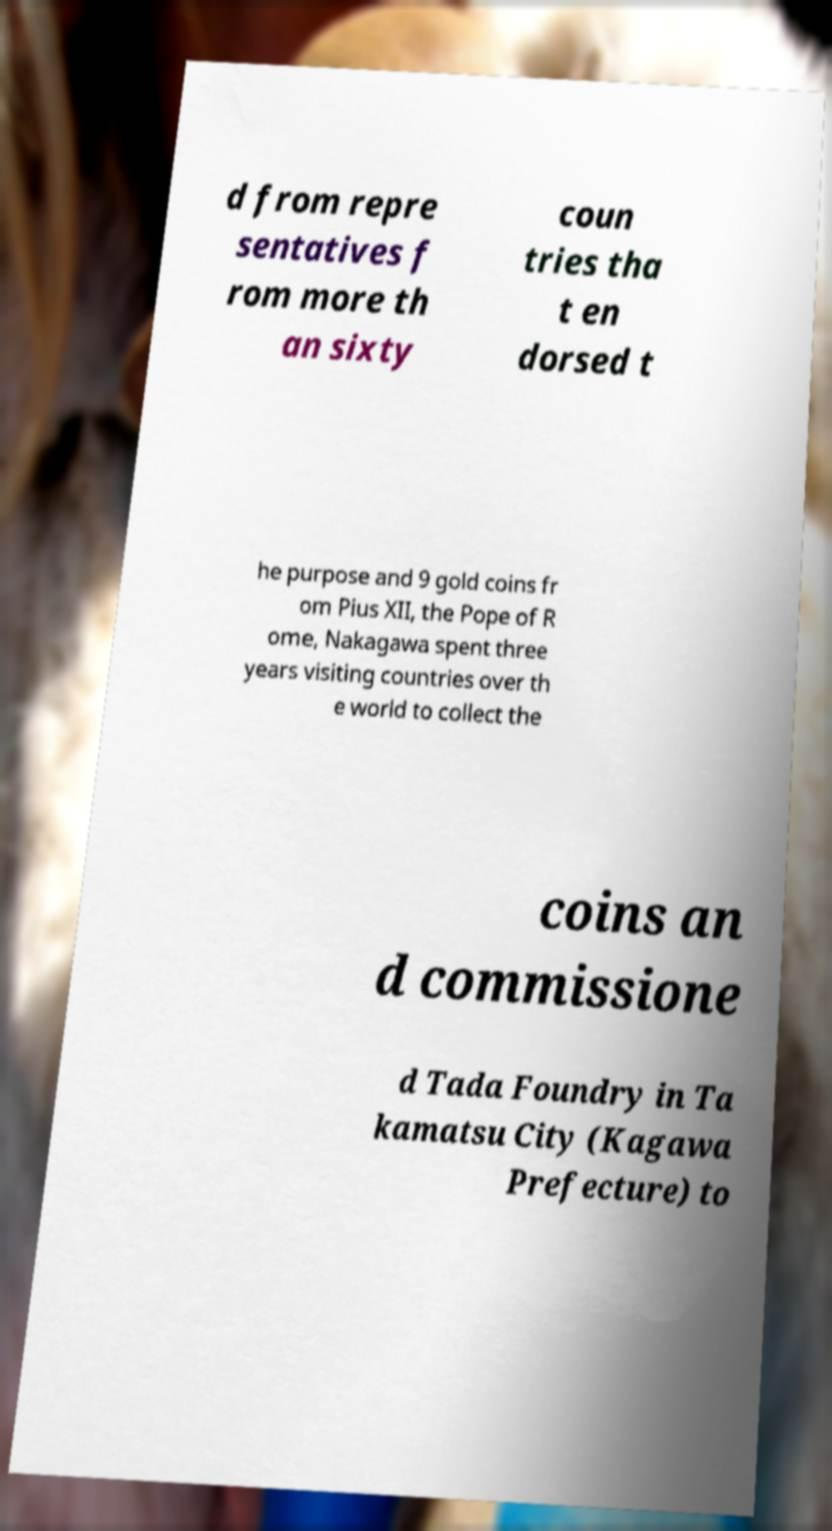Could you extract and type out the text from this image? d from repre sentatives f rom more th an sixty coun tries tha t en dorsed t he purpose and 9 gold coins fr om Pius XII, the Pope of R ome, Nakagawa spent three years visiting countries over th e world to collect the coins an d commissione d Tada Foundry in Ta kamatsu City (Kagawa Prefecture) to 